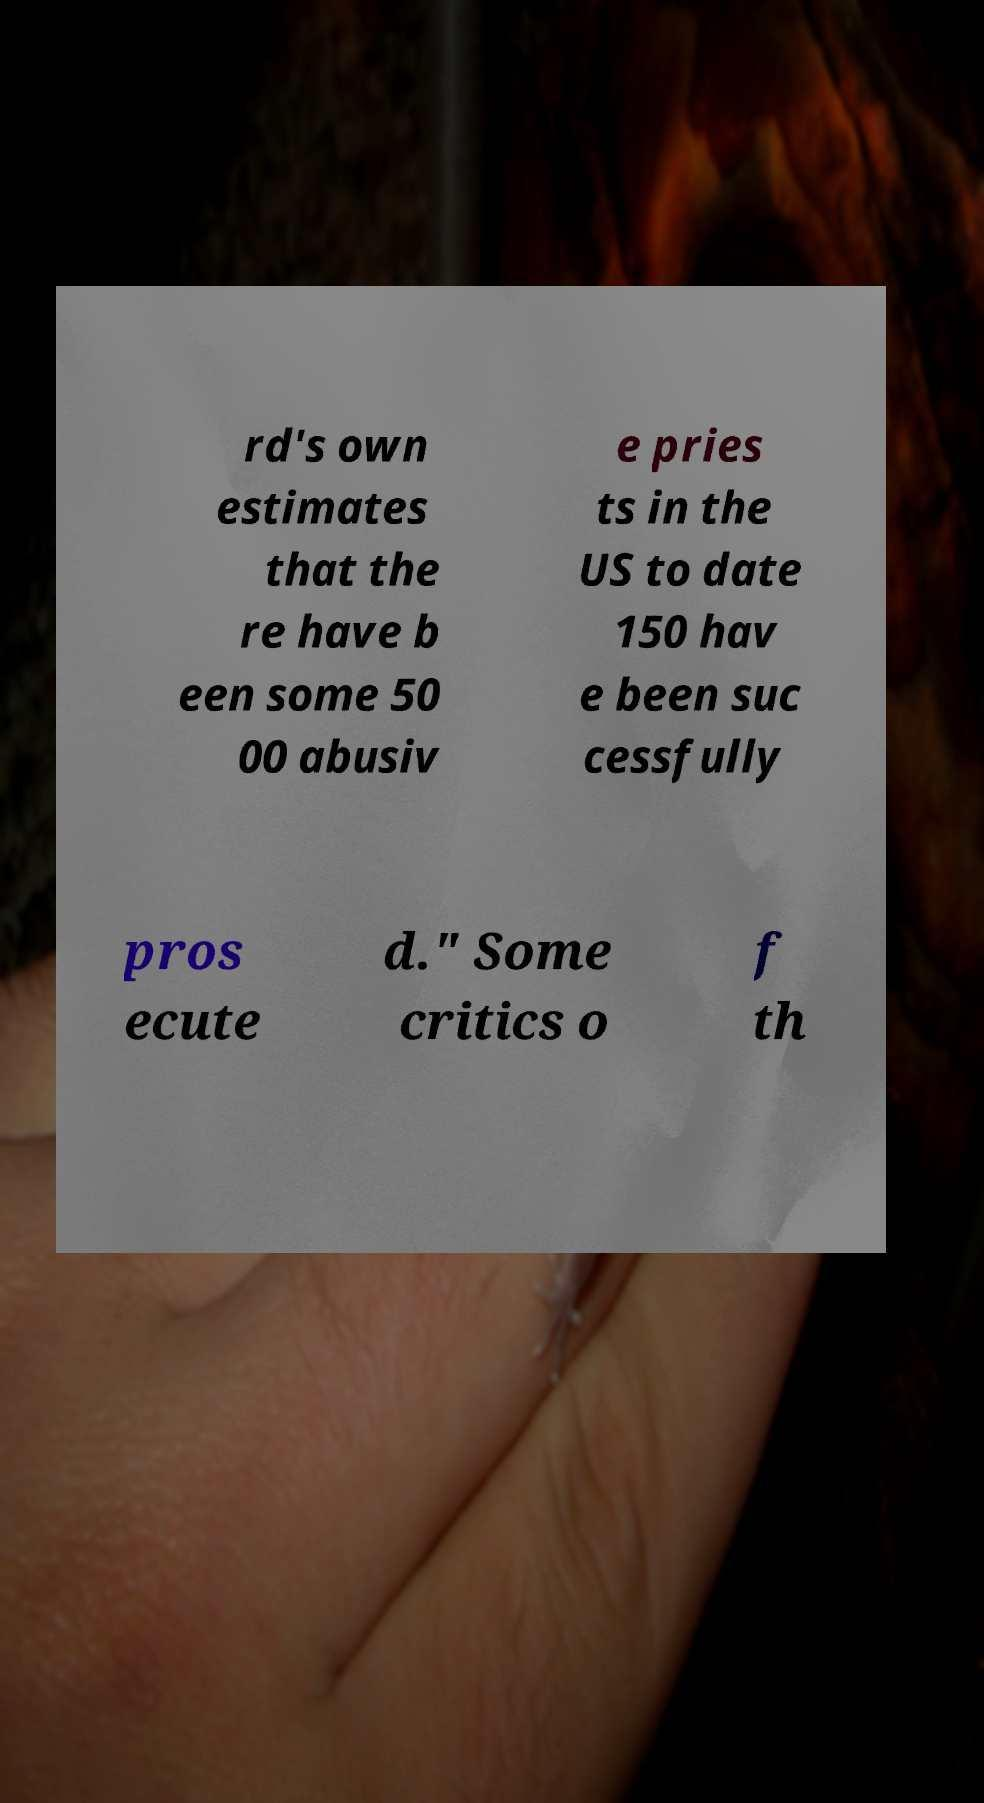For documentation purposes, I need the text within this image transcribed. Could you provide that? rd's own estimates that the re have b een some 50 00 abusiv e pries ts in the US to date 150 hav e been suc cessfully pros ecute d." Some critics o f th 